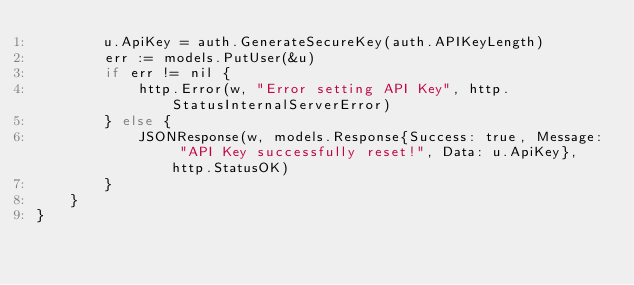<code> <loc_0><loc_0><loc_500><loc_500><_Go_>		u.ApiKey = auth.GenerateSecureKey(auth.APIKeyLength)
		err := models.PutUser(&u)
		if err != nil {
			http.Error(w, "Error setting API Key", http.StatusInternalServerError)
		} else {
			JSONResponse(w, models.Response{Success: true, Message: "API Key successfully reset!", Data: u.ApiKey}, http.StatusOK)
		}
	}
}
</code> 